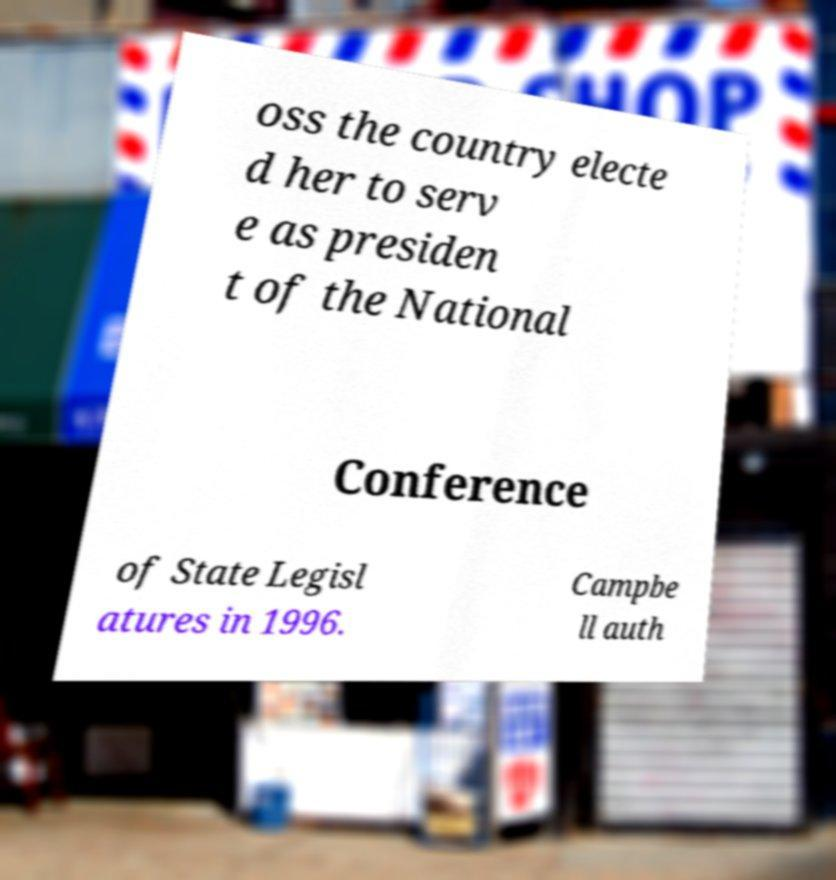Could you assist in decoding the text presented in this image and type it out clearly? oss the country electe d her to serv e as presiden t of the National Conference of State Legisl atures in 1996. Campbe ll auth 